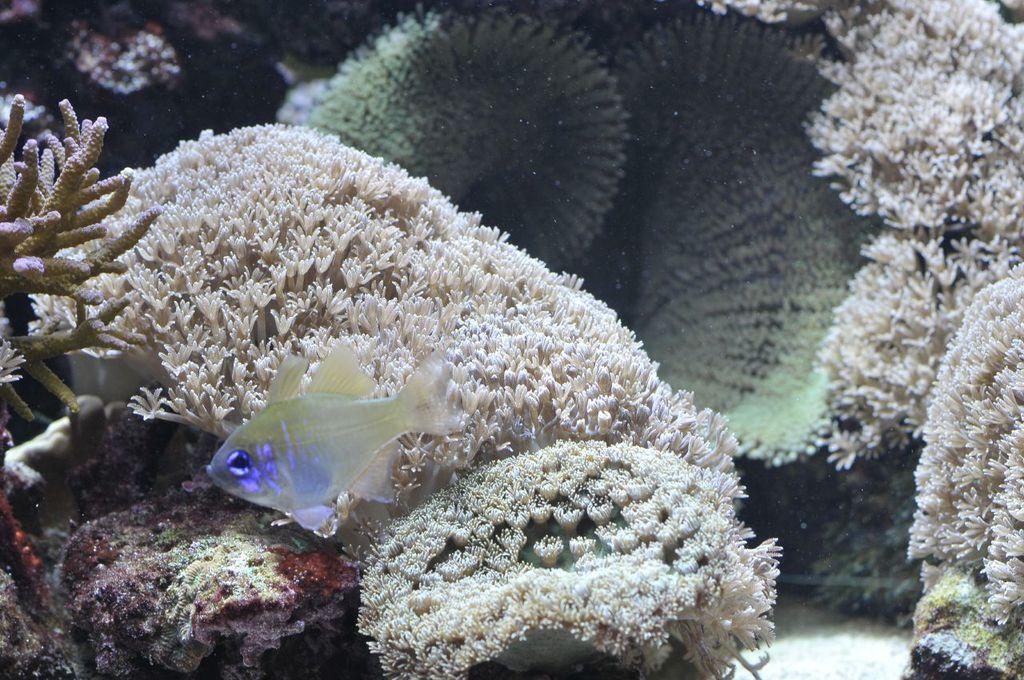Can you describe this image briefly? This picture is taken inside the water. In this image, on the left side, we can see a fish. In the background, we can see some plants. 